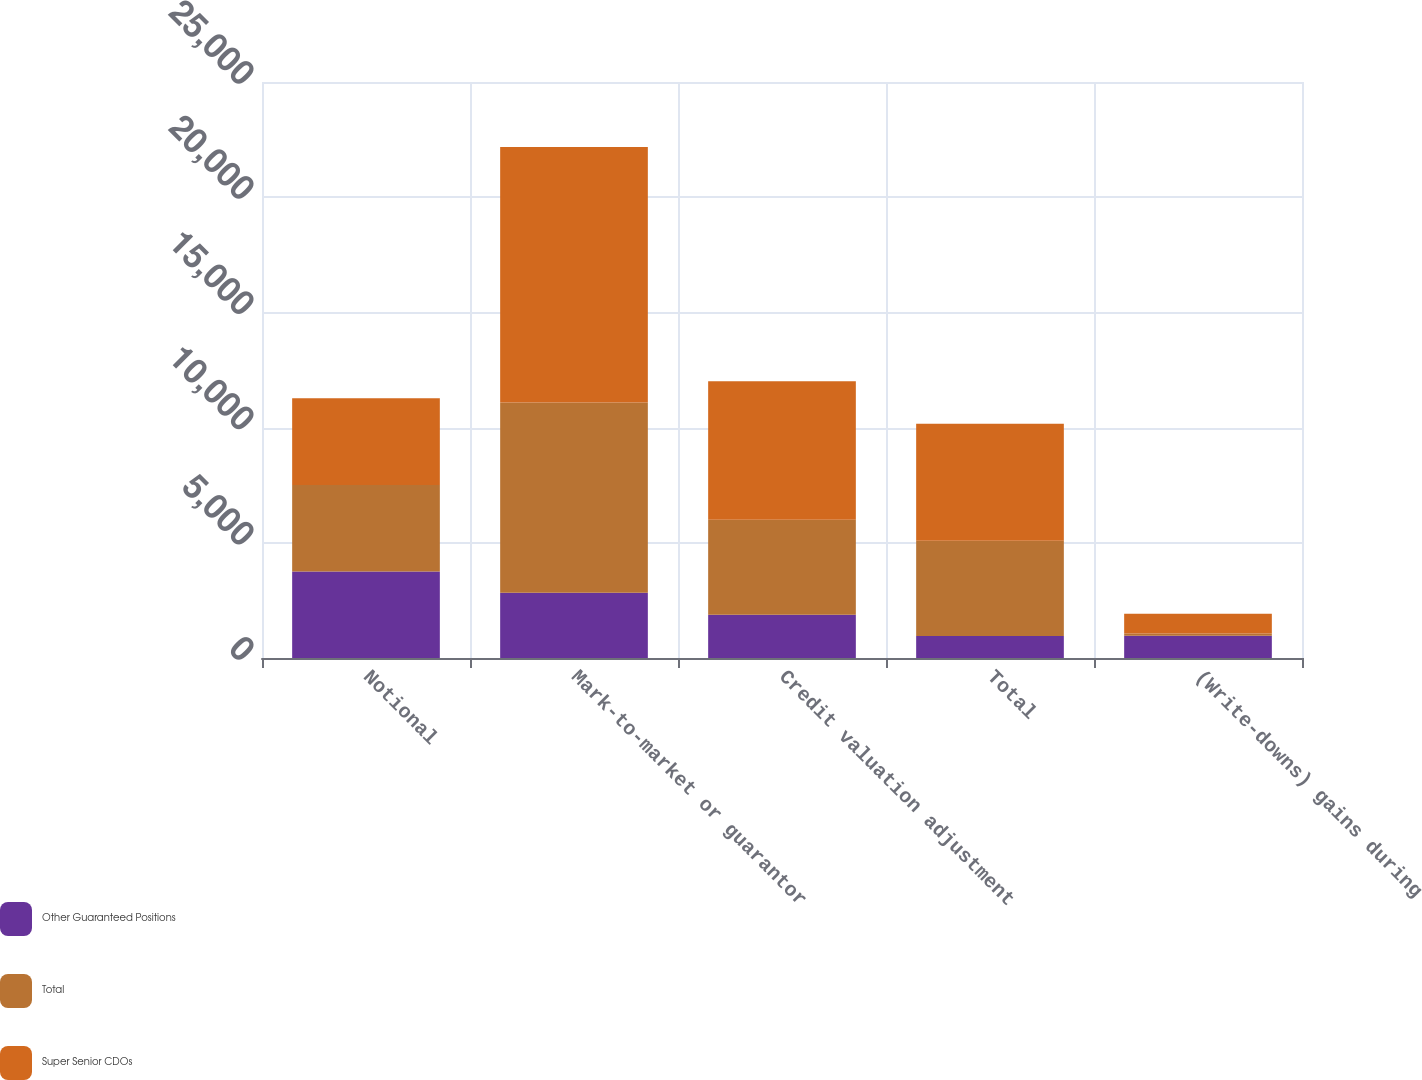Convert chart. <chart><loc_0><loc_0><loc_500><loc_500><stacked_bar_chart><ecel><fcel>Notional<fcel>Mark-to-market or guarantor<fcel>Credit valuation adjustment<fcel>Total<fcel>(Write-downs) gains during<nl><fcel>Other Guaranteed Positions<fcel>3757<fcel>2833<fcel>1873<fcel>960<fcel>961<nl><fcel>Total<fcel>3757<fcel>8256<fcel>4132<fcel>4124<fcel>98<nl><fcel>Super Senior CDOs<fcel>3757<fcel>11089<fcel>6005<fcel>5084<fcel>863<nl></chart> 